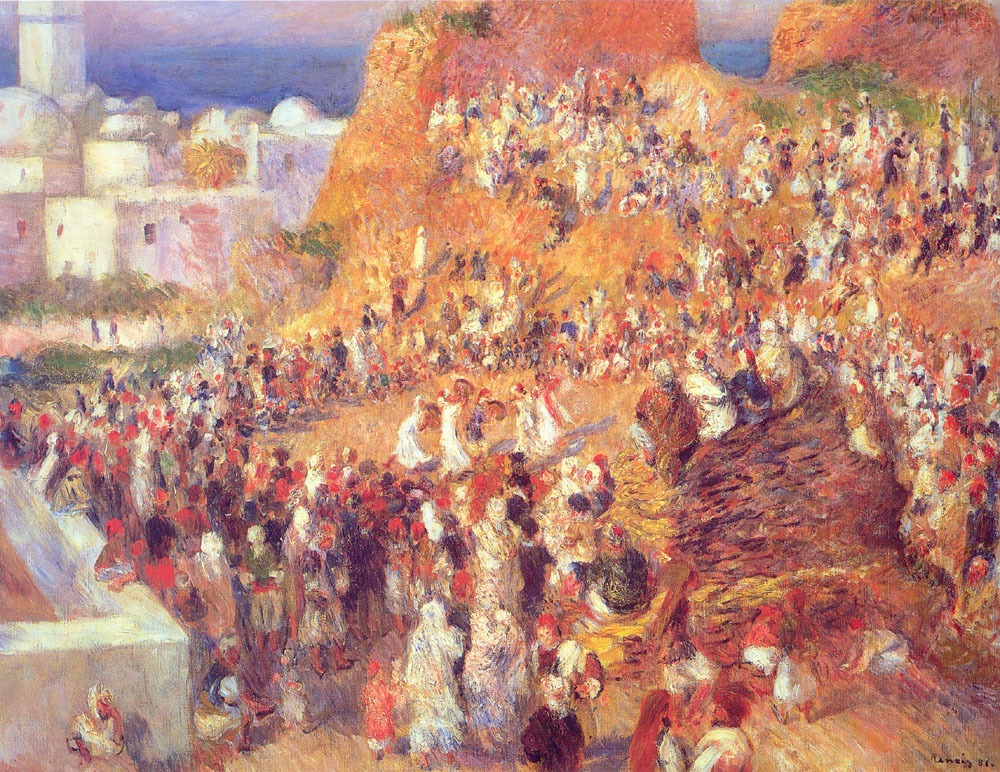Can you imagine what kind of goods might be sold in this market? Given the Mediterranean setting in the painting, one might imagine the market offering a variety of goods such as fresh fruits and vegetables, colorful textiles, handcrafted ceramics, and aromatic spices. The open-air nature of the market suggests the presence of food vendors, perhaps selling local delicacies or fresh seafood. Artisans might also have stalls displaying handmade jewelry, woven baskets, and other regional crafts that reflect the cultural heritage of the area. 